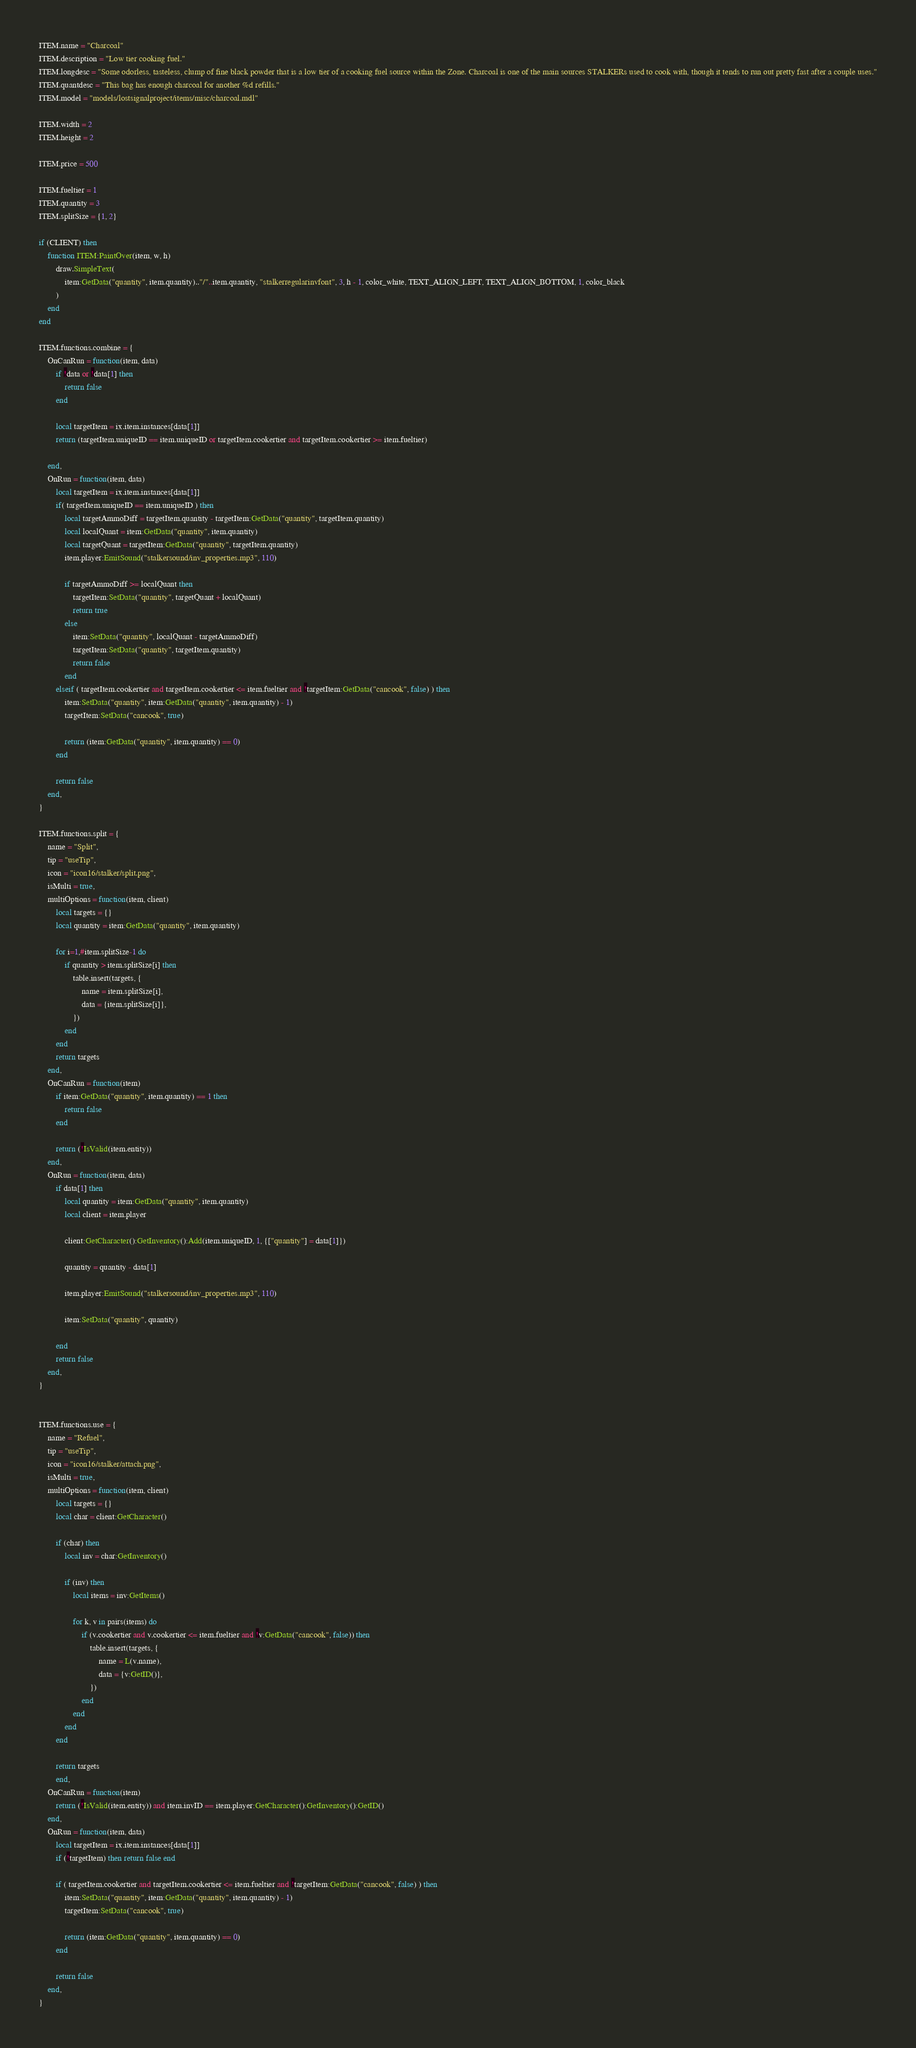Convert code to text. <code><loc_0><loc_0><loc_500><loc_500><_Lua_>ITEM.name = "Charcoal"
ITEM.description = "Low tier cooking fuel."
ITEM.longdesc = "Some odorless, tasteless, clump of fine black powder that is a low tier of a cooking fuel source within the Zone. Charcoal is one of the main sources STALKERs used to cook with, though it tends to run out pretty fast after a couple uses."
ITEM.quantdesc = "This bag has enough charcoal for another %d refills."
ITEM.model = "models/lostsignalproject/items/misc/charcoal.mdl"

ITEM.width = 2
ITEM.height = 2

ITEM.price = 500

ITEM.fueltier = 1
ITEM.quantity = 3
ITEM.splitSize = {1, 2}

if (CLIENT) then
	function ITEM:PaintOver(item, w, h)
		draw.SimpleText(
			item:GetData("quantity", item.quantity).."/"..item.quantity, "stalkerregularinvfont", 3, h - 1, color_white, TEXT_ALIGN_LEFT, TEXT_ALIGN_BOTTOM, 1, color_black
		)
	end
end

ITEM.functions.combine = {
	OnCanRun = function(item, data)
		if !data or !data[1] then
			return false
		end

		local targetItem = ix.item.instances[data[1]]
		return (targetItem.uniqueID == item.uniqueID or targetItem.cookertier and targetItem.cookertier >= item.fueltier)

	end,
	OnRun = function(item, data)
		local targetItem = ix.item.instances[data[1]]
		if( targetItem.uniqueID == item.uniqueID ) then
			local targetAmmoDiff = targetItem.quantity - targetItem:GetData("quantity", targetItem.quantity)
			local localQuant = item:GetData("quantity", item.quantity)
			local targetQuant = targetItem:GetData("quantity", targetItem.quantity)
			item.player:EmitSound("stalkersound/inv_properties.mp3", 110)

			if targetAmmoDiff >= localQuant then
				targetItem:SetData("quantity", targetQuant + localQuant)
				return true
			else
				item:SetData("quantity", localQuant - targetAmmoDiff)
				targetItem:SetData("quantity", targetItem.quantity)
				return false
			end
		elseif ( targetItem.cookertier and targetItem.cookertier <= item.fueltier and !targetItem:GetData("cancook", false) ) then
			item:SetData("quantity", item:GetData("quantity", item.quantity) - 1)
			targetItem:SetData("cancook", true)

			return (item:GetData("quantity", item.quantity) == 0)
		end

		return false
	end,
}

ITEM.functions.split = {
    name = "Split",
    tip = "useTip",
    icon = "icon16/stalker/split.png",
    isMulti = true,
    multiOptions = function(item, client)
		local targets = {}
        local quantity = item:GetData("quantity", item.quantity)

        for i=1,#item.splitSize-1 do
			if quantity > item.splitSize[i] then
				table.insert(targets, {
					name = item.splitSize[i],
					data = {item.splitSize[i]},
				})
			end
		end
        return targets
	end,
	OnCanRun = function(item)
		if item:GetData("quantity", item.quantity) == 1 then
			return false
		end

		return (!IsValid(item.entity))
	end,
    OnRun = function(item, data)
		if data[1] then
			local quantity = item:GetData("quantity", item.quantity)
			local client = item.player

			client:GetCharacter():GetInventory():Add(item.uniqueID, 1, {["quantity"] = data[1]})

			quantity = quantity - data[1]

			item.player:EmitSound("stalkersound/inv_properties.mp3", 110)

			item:SetData("quantity", quantity)

		end
		return false
	end,
}


ITEM.functions.use = {
	name = "Refuel",
	tip = "useTip",
	icon = "icon16/stalker/attach.png",
	isMulti = true,
	multiOptions = function(item, client)
		local targets = {}
		local char = client:GetCharacter()

		if (char) then
			local inv = char:GetInventory()

			if (inv) then
				local items = inv:GetItems()

				for k, v in pairs(items) do
					if (v.cookertier and v.cookertier <= item.fueltier and !v:GetData("cancook", false)) then
						table.insert(targets, {
							name = L(v.name),
							data = {v:GetID()},
						})
					end
				end
			end
		end

		return targets
		end,
	OnCanRun = function(item)
		return (!IsValid(item.entity)) and item.invID == item.player:GetCharacter():GetInventory():GetID()
	end,
	OnRun = function(item, data)
		local targetItem = ix.item.instances[data[1]]
		if (!targetItem) then return false end

		if ( targetItem.cookertier and targetItem.cookertier <= item.fueltier and !targetItem:GetData("cancook", false) ) then
			item:SetData("quantity", item:GetData("quantity", item.quantity) - 1)
			targetItem:SetData("cancook", true)

			return (item:GetData("quantity", item.quantity) == 0)
		end

		return false
	end,
}
</code> 